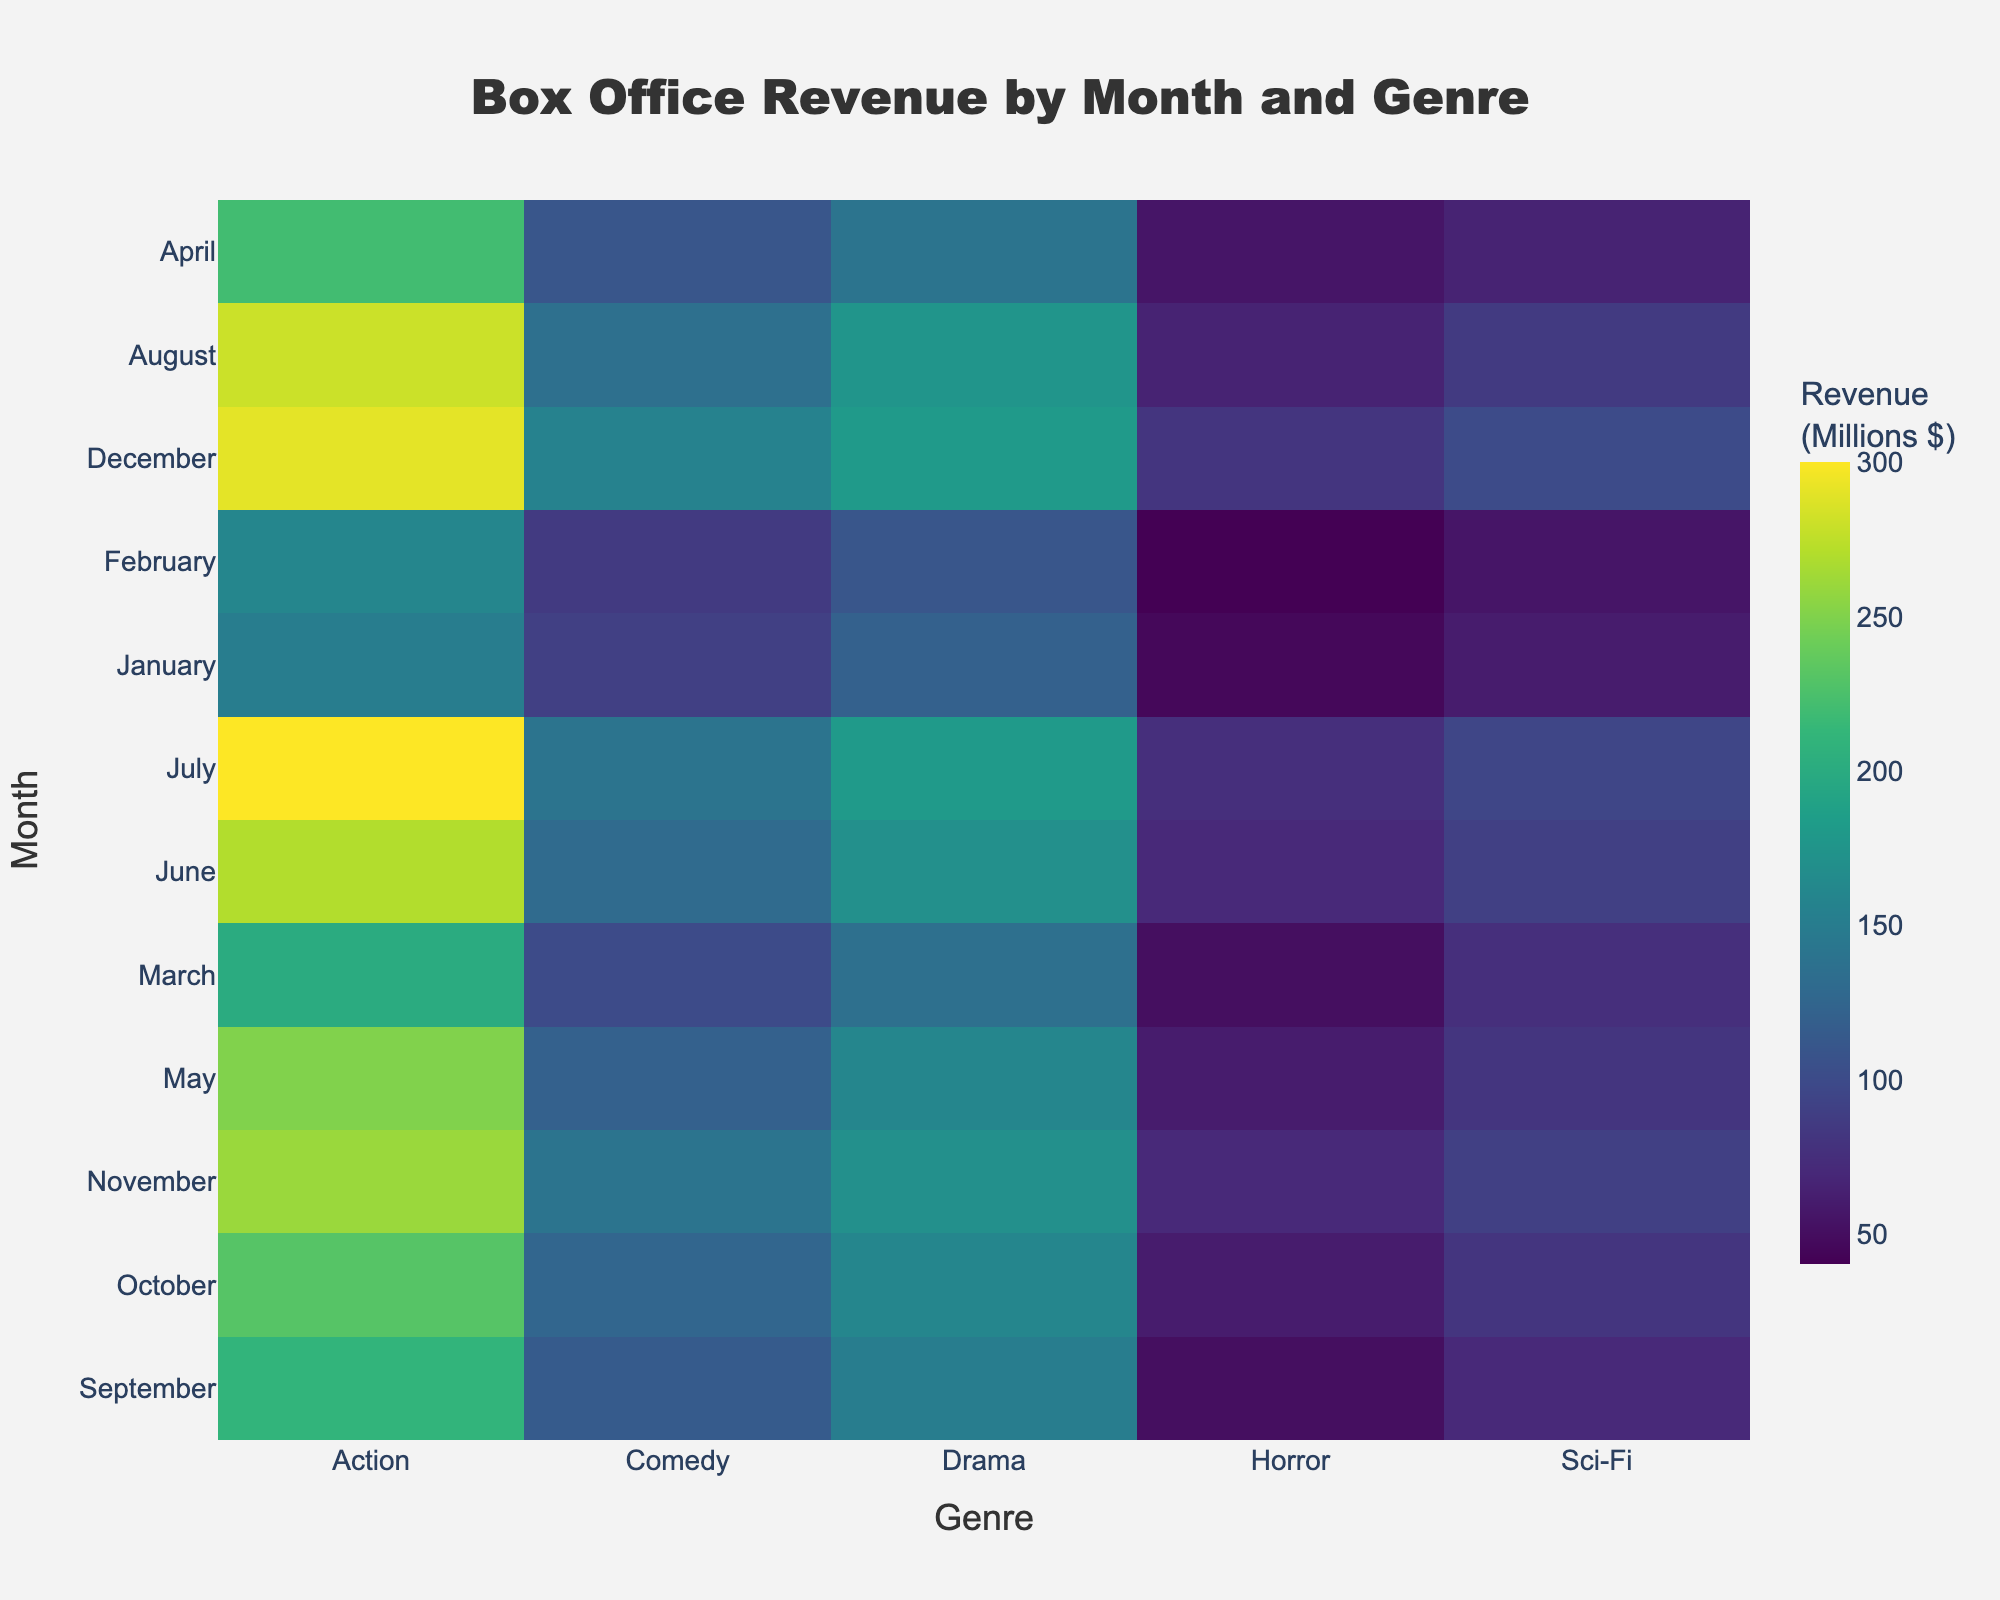What is the title of the heatmap? The title of a figure is typically found at the top and is designed to give an overview of the data presented. In this heatmap, it is clearly displayed.
Answer: Box Office Revenue by Month and Genre Which month has the highest revenue for Action movies? To find the highest revenue for Action movies, locate the column labeled "Action" and identify the cell with the highest value.
Answer: July What is the average revenue for Comedy movies in the first quarter (January to March)? First, find the revenue values for Comedy in January, February, and March: 90, 85, and 100. Add these values and then divide by 3. (90+85+100)/3 = 275/3 = 91.67
Answer: 91.67 In which genre and month combination is the lowest revenue recorded? Scan through the entire heatmap to find the cell with the lowest revenue. The smallest value is 40 for Horror in February.
Answer: Horror, February Compare the revenue for Drama movies in June and July. Which month had higher revenue and by how much? June: 170, July: 180. Subtract the two values to find the difference (180 - 170 = 10). July has higher revenue by 10 million.
Answer: July by 10 During which month does the revenue for Sci-Fi movies reach its peak? Locate the "Sci-Fi" column and identify the month with the highest value. The peak revenue for Sci-Fi movies is 100 in December.
Answer: December What's the total revenue for Horror movies across all months? Sum the revenue values for Horror movies from all months: 45+40+50+55+60+70+75+65+50+60+70+80. This equals 720.
Answer: 720 Which month has the most evenly distributed revenue across all genres? Look for the month where the revenues are closest to each other across genres. By comparing January, February, etc., August has values close to each other: Action (280), Drama (175), Comedy (135), Sci-Fi (85), Horror (65).
Answer: August What is the revenue difference between Comedy and Drama movies in December? Comedy revenue in December is 155, and Drama revenue in December is 180. Subtract Comedy revenue from Drama (180 - 155 = 25).
Answer: 25 